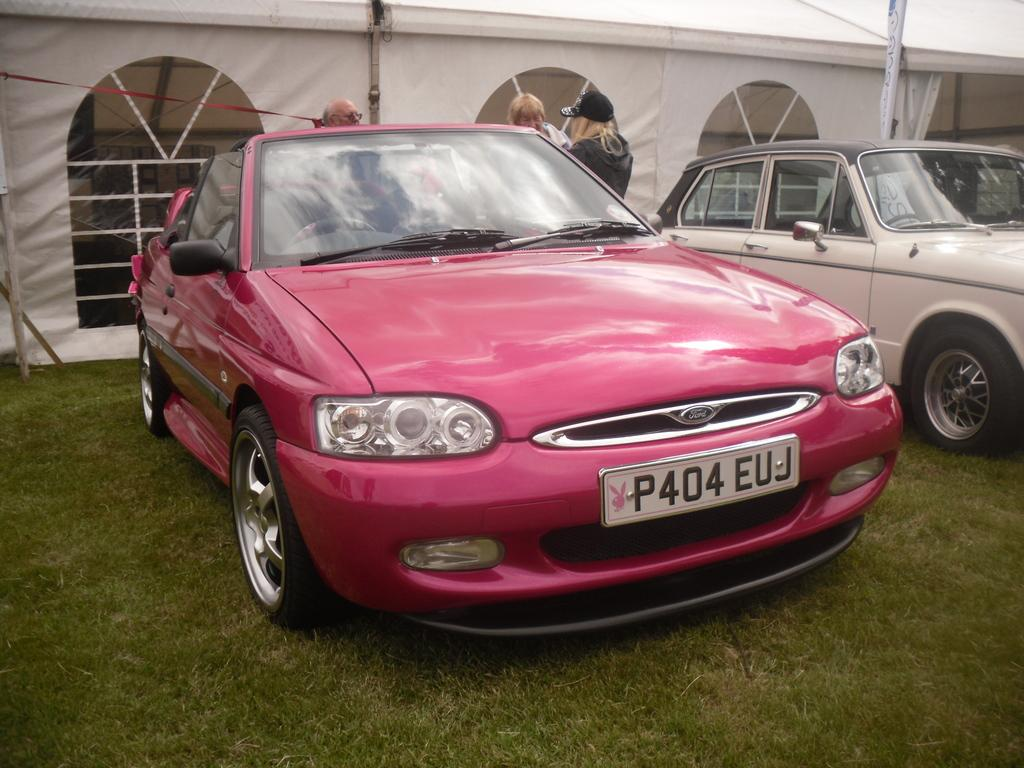<image>
Give a short and clear explanation of the subsequent image. A pink card with a license plate that says P404 EUJ. 